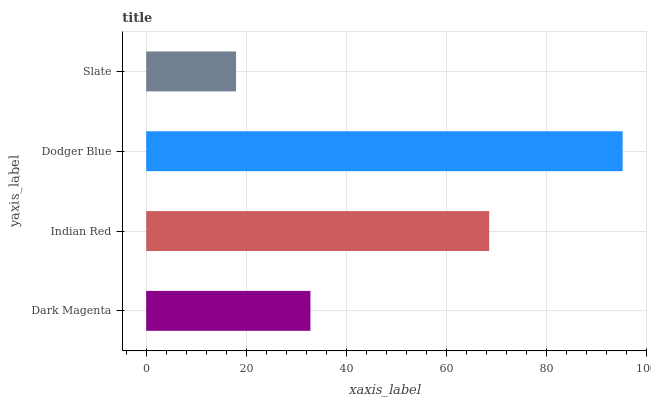Is Slate the minimum?
Answer yes or no. Yes. Is Dodger Blue the maximum?
Answer yes or no. Yes. Is Indian Red the minimum?
Answer yes or no. No. Is Indian Red the maximum?
Answer yes or no. No. Is Indian Red greater than Dark Magenta?
Answer yes or no. Yes. Is Dark Magenta less than Indian Red?
Answer yes or no. Yes. Is Dark Magenta greater than Indian Red?
Answer yes or no. No. Is Indian Red less than Dark Magenta?
Answer yes or no. No. Is Indian Red the high median?
Answer yes or no. Yes. Is Dark Magenta the low median?
Answer yes or no. Yes. Is Dark Magenta the high median?
Answer yes or no. No. Is Dodger Blue the low median?
Answer yes or no. No. 